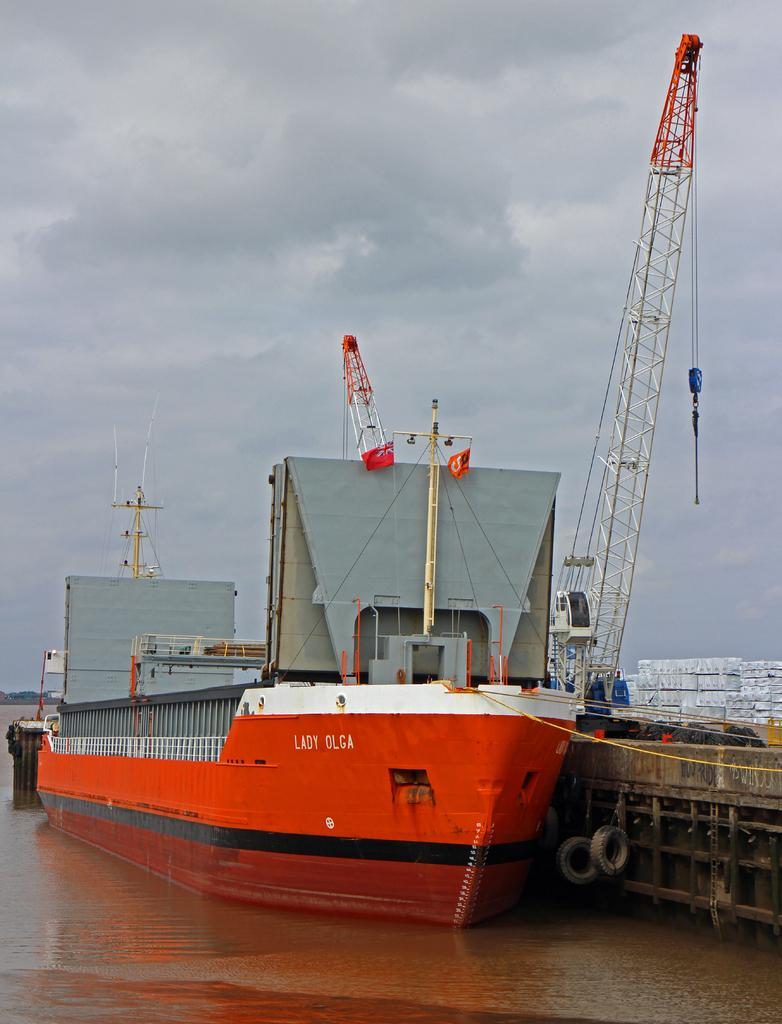What is positioned above the water in the image? There is a boat above the water in the image. What type of objects can be seen in the image? There are tyres, a pole, a crane, and other objects in the image. What is visible in the background of the image? The sky with clouds is visible in the background of the image. How many birds are in the flock flying over the boat in the image? There are no birds or flocks visible in the image; it features a boat above the water, objects, and a sky with clouds in the background. 